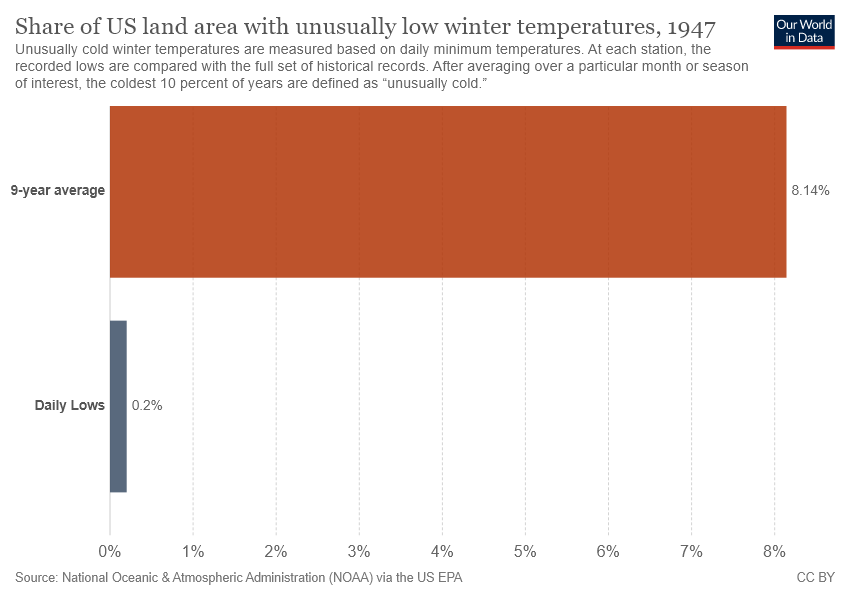Identify some key points in this picture. The total of the two values is less than or equal to 9. The average share of land in the United States with unusually low winter temperatures over the past 9 years is 0.0814.. 